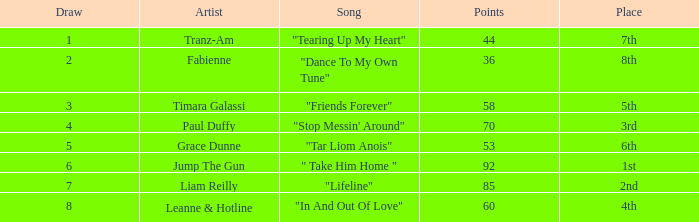What is paul duffy's maximum draw exceeding 60 points? 4.0. 